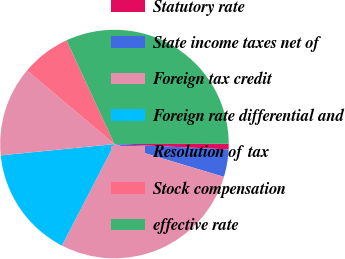Convert chart. <chart><loc_0><loc_0><loc_500><loc_500><pie_chart><fcel>Statutory rate<fcel>State income taxes net of<fcel>Foreign tax credit<fcel>Foreign rate differential and<fcel>Resolution of tax<fcel>Stock compensation<fcel>effective rate<nl><fcel>0.78%<fcel>3.89%<fcel>27.97%<fcel>15.82%<fcel>12.72%<fcel>6.99%<fcel>31.84%<nl></chart> 